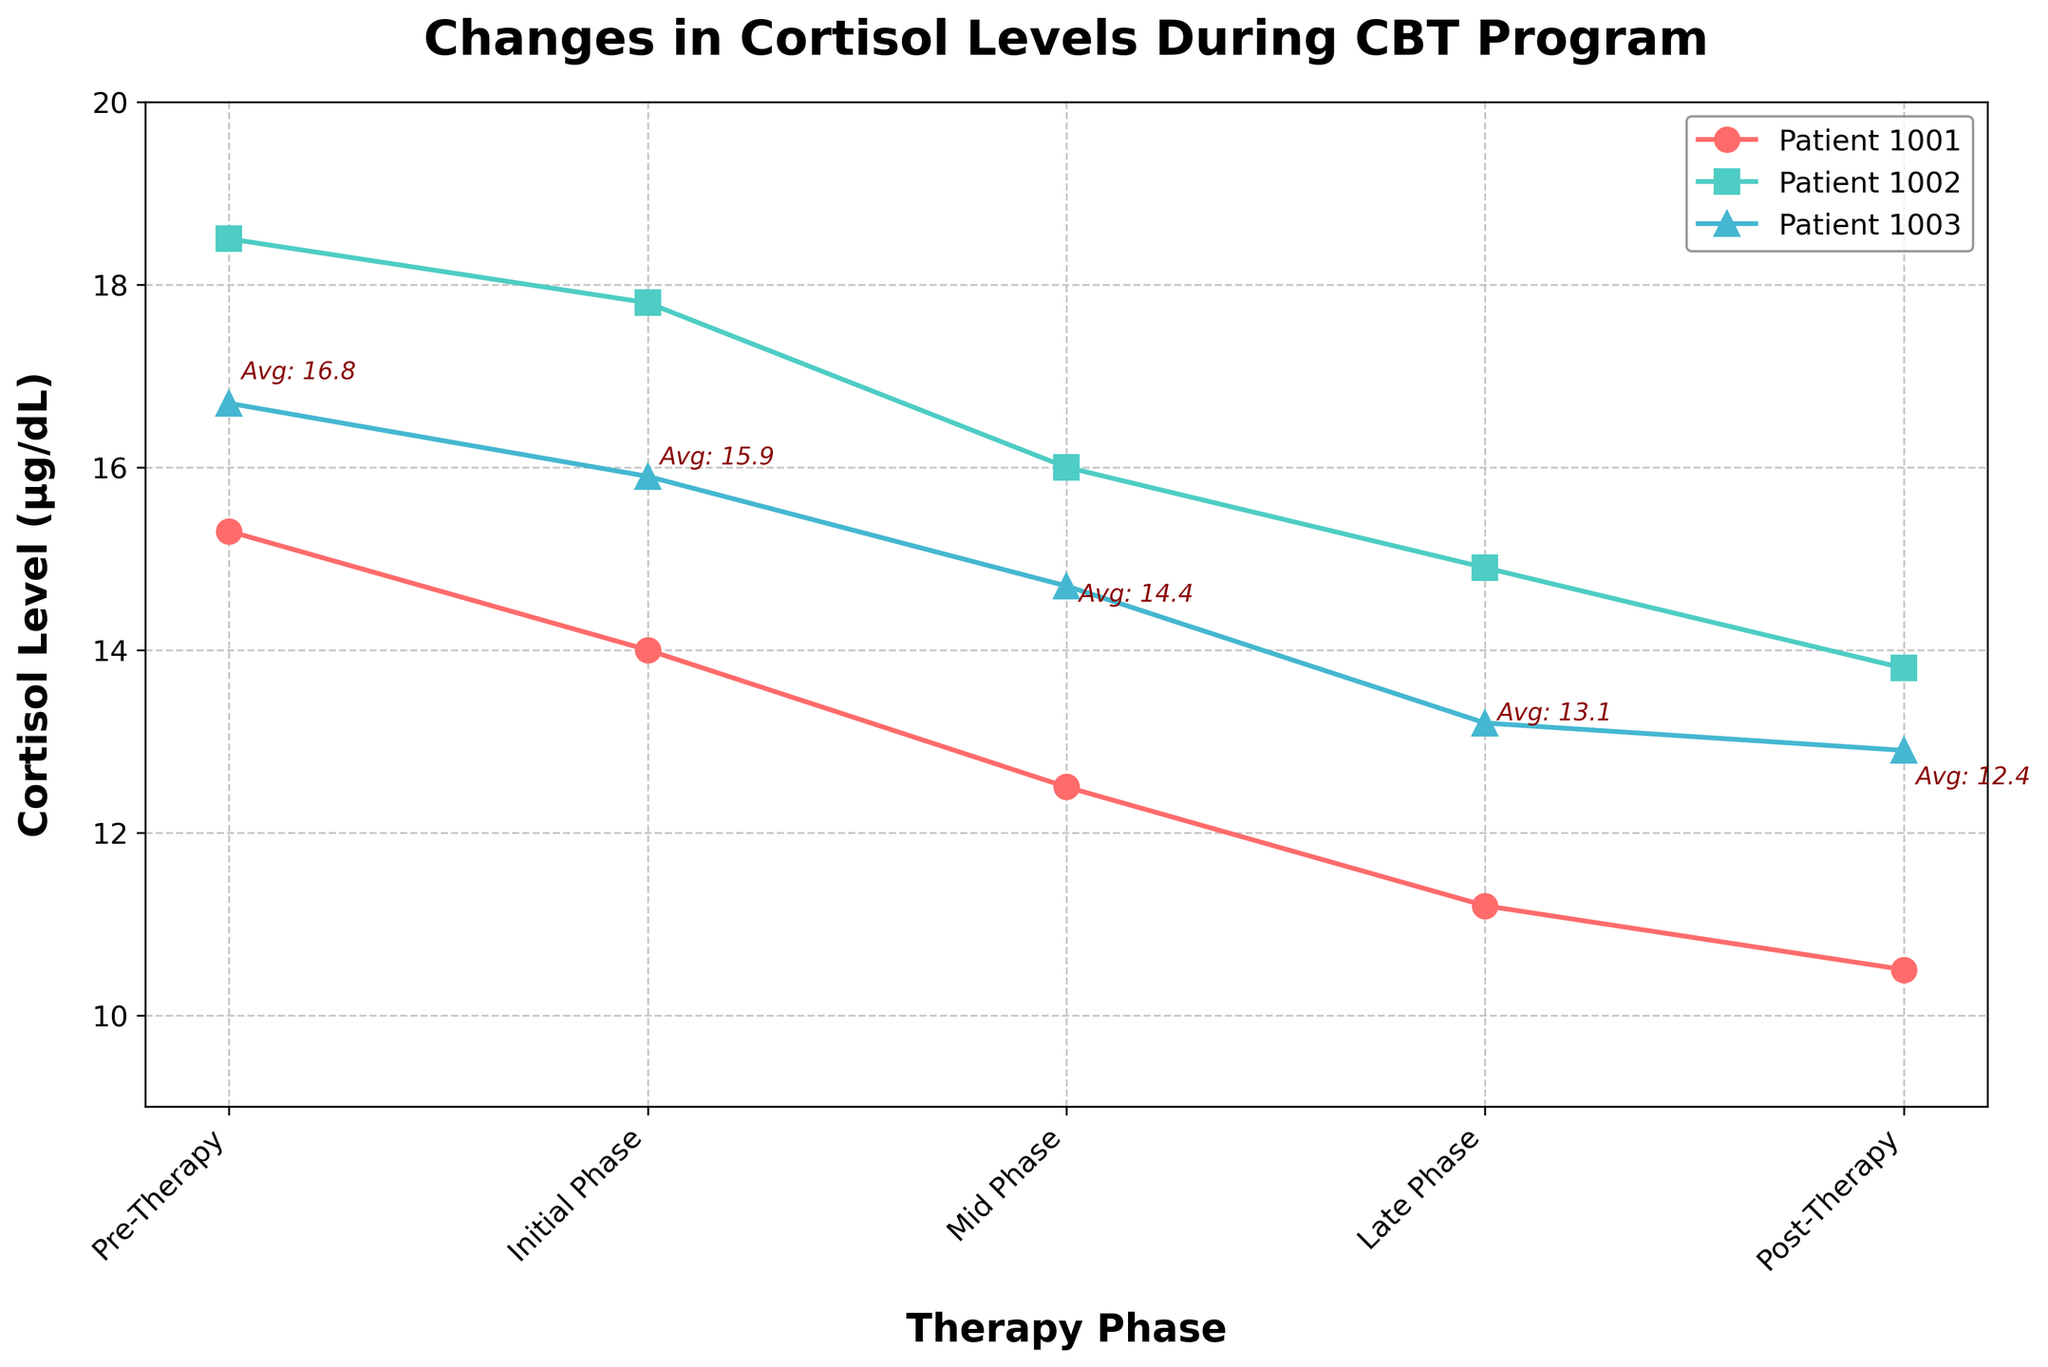What is the overall trend of cortisol levels for Patient 1001 throughout the therapy phases? The cortisol levels for Patient 1001 decreased with each successive phase from Pre-Therapy to Post-Therapy. Starting at 15.3 µg/dL in the Pre-Therapy phase, then dropping progressively: 14.0 (Initial Phase), 12.5 (Mid Phase), 11.2 (Late Phase), and finally 10.5 µg/dL (Post-Therapy).
Answer: Decreasing What is the average cortisol level in the Pre-Therapy phase? Add the cortisol levels of all patients in the Pre-Therapy phase and divide by the number of patients: (15.3 + 18.5 + 16.7) / 3 = 50.5 / 3 = 16.8 µg/dL.
Answer: 16.8 µg/dL Which patient had the highest cortisol level in the Mid Phase? Look for the highest point in the Mid Phase portion of the plot. Patient 1002 has the highest cortisol level at 16.0 µg/dL.
Answer: Patient 1002 What is the difference in cortisol levels between the Pre-Therapy phase and the Post-Therapy phase for Patient 1003? Subtract the Post-Therapy cortisol level from the Pre-Therapy cortisol level for Patient 1003: 16.7 - 12.9 = 3.8 µg/dL.
Answer: 3.8 µg/dL How do the average cortisol levels compare between the Initial Phase and the Late Phase? Calculate the average for each phase: Initial Phase: (14.0 + 17.8 + 15.9) / 3 = 15.9 µg/dL. Late Phase: (11.2 + 14.9 + 13.2) / 3 = 13.1 µg/dL. The average cortisol level is higher in the Initial Phase compared to the Late Phase.
Answer: Initial Phase is higher What are the cortisol levels for Patient 1001 at each phase? Read the values directly from the figure: Pre-Therapy (15.3 µg/dL), Initial Phase (14.0 µg/dL), Mid Phase (12.5 µg/dL), Late Phase (11.2 µg/dL), Post-Therapy (10.5 µg/dL).
Answer: 15.3, 14.0, 12.5, 11.2, 10.5 µg/dL During which phase did Patient 1002 experience the largest change in cortisol levels? Calculate the absolute differences between consecutive phases: Pre-Therapy to Initial Phase: 18.5 - 17.8 = 0.7 µg/dL, Initial Phase to Mid Phase: 17.8 - 16.0 = 1.8 µg/dL, Mid Phase to Late Phase: 16.0 - 14.9 = 1.1 µg/dL, Late Phase to Post-Therapy: 14.9 - 13.8 = 1.1 µg/dL. The largest change occurred between the Initial Phase and Mid Phase (1.8 µg/dL).
Answer: Initial to Mid Phase What is the average cortisol level for all patients in the Post-Therapy phase? Add all cortisol levels in the Post-Therapy phase and divide by the number of patients. (10.5 + 13.8 + 12.9) / 3 = 37.2 / 3 = 12.4 µg/dL.
Answer: 12.4 µg/dL Which patient showed the least variability in cortisol levels across all phases? Calculate the range for each patient. Patient 1001: 15.3 - 10.5 = 4.8, Patient 1002: 18.5 - 13.8 = 4.7, Patient 1003: 16.7 - 12.9 = 3.8. Therefore, Patient 1003 showed the least variability.
Answer: Patient 1003 